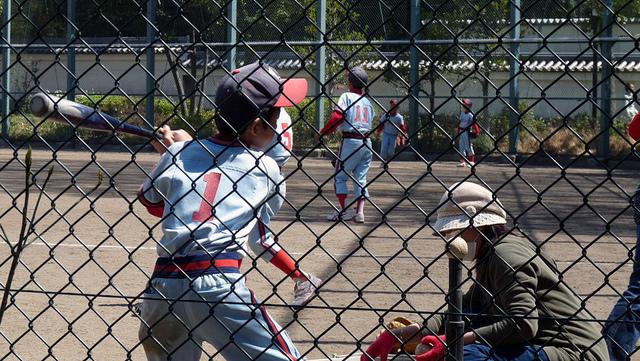What is the batter wearing on his head?
Write a very short answer. Hat. Is the batter, wearing the number one, right or left handed?
Give a very brief answer. Left. How old are the players?
Write a very short answer. 10. What game is being played?
Keep it brief. Baseball. 